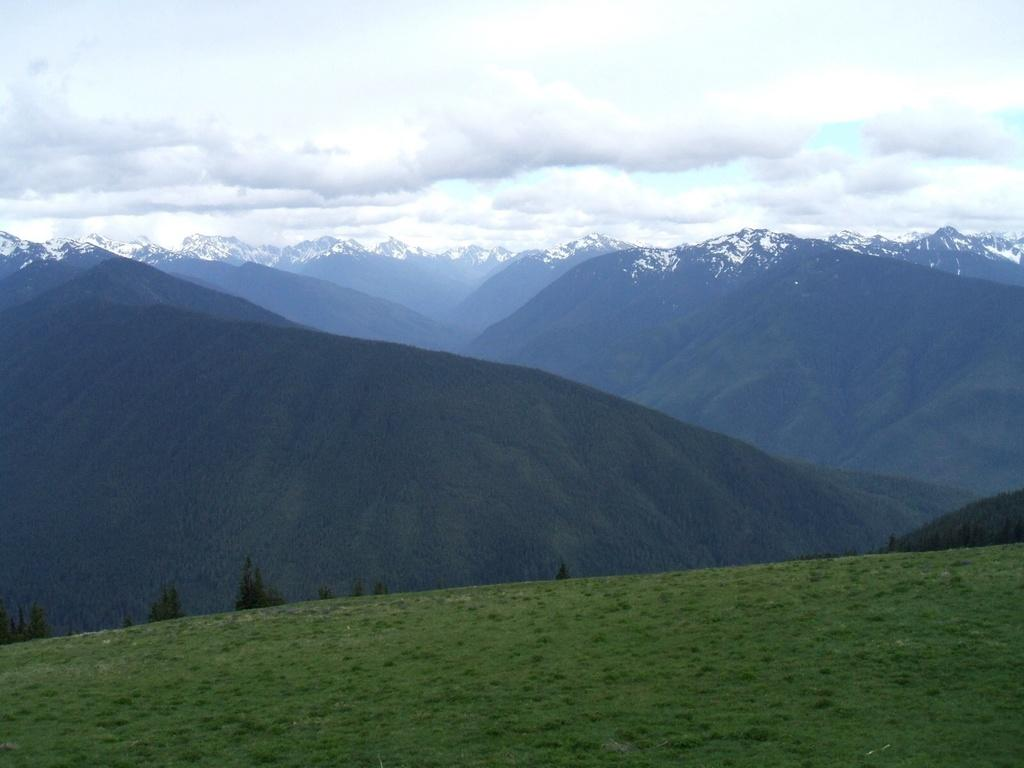What type of natural environment is visible in the image? There is grass visible in the image. What type of geographical feature can be seen in the distance? There are mountains in the image. What is the condition of the sky in the image? The sky is cloudy in the image. Is there a scarf floating on the lake in the image? There is no lake present in the image, so it is not possible to determine if there is a scarf floating on it. 